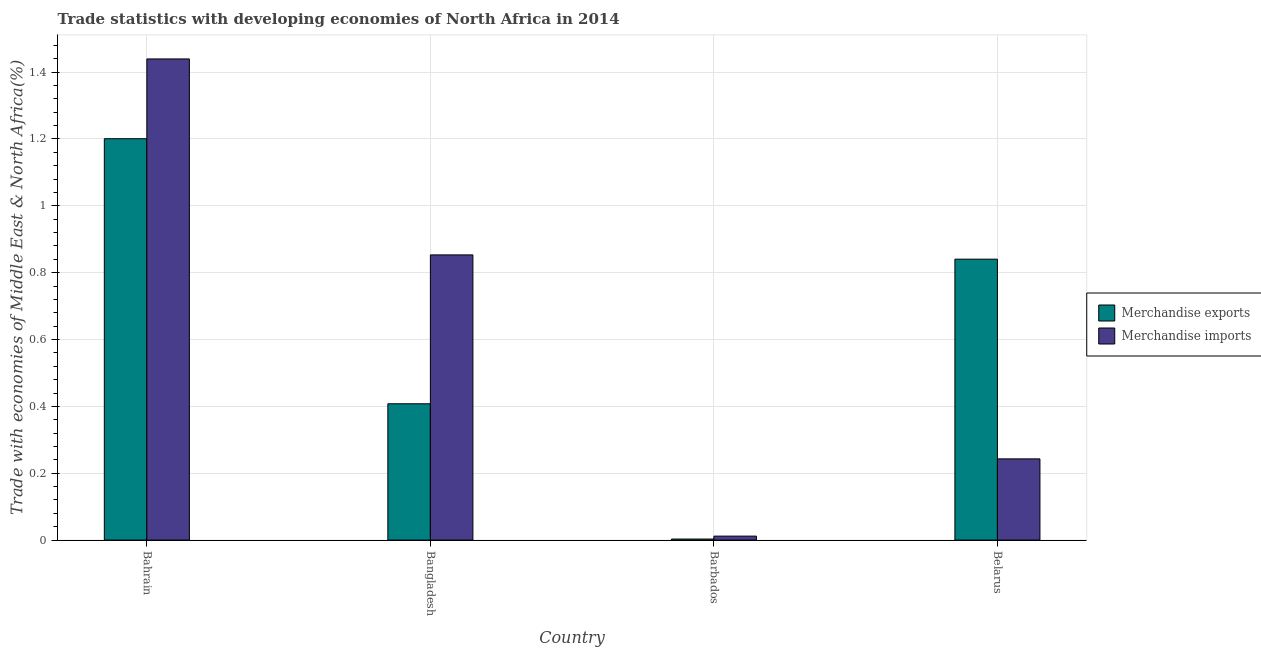Are the number of bars on each tick of the X-axis equal?
Your answer should be compact. Yes. How many bars are there on the 3rd tick from the left?
Ensure brevity in your answer.  2. How many bars are there on the 1st tick from the right?
Provide a short and direct response. 2. What is the label of the 2nd group of bars from the left?
Your answer should be compact. Bangladesh. In how many cases, is the number of bars for a given country not equal to the number of legend labels?
Keep it short and to the point. 0. What is the merchandise imports in Belarus?
Keep it short and to the point. 0.24. Across all countries, what is the maximum merchandise imports?
Your response must be concise. 1.44. Across all countries, what is the minimum merchandise imports?
Offer a terse response. 0.01. In which country was the merchandise exports maximum?
Keep it short and to the point. Bahrain. In which country was the merchandise exports minimum?
Provide a succinct answer. Barbados. What is the total merchandise imports in the graph?
Your answer should be very brief. 2.55. What is the difference between the merchandise exports in Bangladesh and that in Barbados?
Offer a very short reply. 0.4. What is the difference between the merchandise imports in Belarus and the merchandise exports in Barbados?
Your response must be concise. 0.24. What is the average merchandise imports per country?
Keep it short and to the point. 0.64. What is the difference between the merchandise exports and merchandise imports in Bangladesh?
Your answer should be compact. -0.45. In how many countries, is the merchandise imports greater than 0.6000000000000001 %?
Your answer should be very brief. 2. What is the ratio of the merchandise imports in Bangladesh to that in Belarus?
Make the answer very short. 3.51. Is the merchandise exports in Bahrain less than that in Barbados?
Your answer should be compact. No. What is the difference between the highest and the second highest merchandise exports?
Provide a succinct answer. 0.36. What is the difference between the highest and the lowest merchandise imports?
Your response must be concise. 1.43. What does the 2nd bar from the right in Barbados represents?
Your answer should be very brief. Merchandise exports. Does the graph contain grids?
Give a very brief answer. Yes. What is the title of the graph?
Your answer should be compact. Trade statistics with developing economies of North Africa in 2014. What is the label or title of the Y-axis?
Offer a very short reply. Trade with economies of Middle East & North Africa(%). What is the Trade with economies of Middle East & North Africa(%) in Merchandise exports in Bahrain?
Provide a succinct answer. 1.2. What is the Trade with economies of Middle East & North Africa(%) in Merchandise imports in Bahrain?
Offer a very short reply. 1.44. What is the Trade with economies of Middle East & North Africa(%) of Merchandise exports in Bangladesh?
Keep it short and to the point. 0.41. What is the Trade with economies of Middle East & North Africa(%) of Merchandise imports in Bangladesh?
Offer a very short reply. 0.85. What is the Trade with economies of Middle East & North Africa(%) in Merchandise exports in Barbados?
Give a very brief answer. 0. What is the Trade with economies of Middle East & North Africa(%) of Merchandise imports in Barbados?
Your answer should be very brief. 0.01. What is the Trade with economies of Middle East & North Africa(%) of Merchandise exports in Belarus?
Offer a terse response. 0.84. What is the Trade with economies of Middle East & North Africa(%) in Merchandise imports in Belarus?
Your response must be concise. 0.24. Across all countries, what is the maximum Trade with economies of Middle East & North Africa(%) in Merchandise exports?
Your response must be concise. 1.2. Across all countries, what is the maximum Trade with economies of Middle East & North Africa(%) in Merchandise imports?
Make the answer very short. 1.44. Across all countries, what is the minimum Trade with economies of Middle East & North Africa(%) in Merchandise exports?
Make the answer very short. 0. Across all countries, what is the minimum Trade with economies of Middle East & North Africa(%) of Merchandise imports?
Your answer should be compact. 0.01. What is the total Trade with economies of Middle East & North Africa(%) of Merchandise exports in the graph?
Offer a terse response. 2.45. What is the total Trade with economies of Middle East & North Africa(%) in Merchandise imports in the graph?
Ensure brevity in your answer.  2.55. What is the difference between the Trade with economies of Middle East & North Africa(%) of Merchandise exports in Bahrain and that in Bangladesh?
Your answer should be very brief. 0.79. What is the difference between the Trade with economies of Middle East & North Africa(%) in Merchandise imports in Bahrain and that in Bangladesh?
Offer a terse response. 0.59. What is the difference between the Trade with economies of Middle East & North Africa(%) of Merchandise exports in Bahrain and that in Barbados?
Make the answer very short. 1.2. What is the difference between the Trade with economies of Middle East & North Africa(%) in Merchandise imports in Bahrain and that in Barbados?
Offer a very short reply. 1.43. What is the difference between the Trade with economies of Middle East & North Africa(%) of Merchandise exports in Bahrain and that in Belarus?
Provide a succinct answer. 0.36. What is the difference between the Trade with economies of Middle East & North Africa(%) in Merchandise imports in Bahrain and that in Belarus?
Provide a short and direct response. 1.2. What is the difference between the Trade with economies of Middle East & North Africa(%) of Merchandise exports in Bangladesh and that in Barbados?
Your response must be concise. 0.4. What is the difference between the Trade with economies of Middle East & North Africa(%) in Merchandise imports in Bangladesh and that in Barbados?
Ensure brevity in your answer.  0.84. What is the difference between the Trade with economies of Middle East & North Africa(%) of Merchandise exports in Bangladesh and that in Belarus?
Offer a terse response. -0.43. What is the difference between the Trade with economies of Middle East & North Africa(%) in Merchandise imports in Bangladesh and that in Belarus?
Keep it short and to the point. 0.61. What is the difference between the Trade with economies of Middle East & North Africa(%) of Merchandise exports in Barbados and that in Belarus?
Provide a succinct answer. -0.84. What is the difference between the Trade with economies of Middle East & North Africa(%) of Merchandise imports in Barbados and that in Belarus?
Ensure brevity in your answer.  -0.23. What is the difference between the Trade with economies of Middle East & North Africa(%) of Merchandise exports in Bahrain and the Trade with economies of Middle East & North Africa(%) of Merchandise imports in Bangladesh?
Keep it short and to the point. 0.35. What is the difference between the Trade with economies of Middle East & North Africa(%) of Merchandise exports in Bahrain and the Trade with economies of Middle East & North Africa(%) of Merchandise imports in Barbados?
Offer a terse response. 1.19. What is the difference between the Trade with economies of Middle East & North Africa(%) in Merchandise exports in Bahrain and the Trade with economies of Middle East & North Africa(%) in Merchandise imports in Belarus?
Provide a succinct answer. 0.96. What is the difference between the Trade with economies of Middle East & North Africa(%) in Merchandise exports in Bangladesh and the Trade with economies of Middle East & North Africa(%) in Merchandise imports in Barbados?
Ensure brevity in your answer.  0.4. What is the difference between the Trade with economies of Middle East & North Africa(%) in Merchandise exports in Bangladesh and the Trade with economies of Middle East & North Africa(%) in Merchandise imports in Belarus?
Your response must be concise. 0.16. What is the difference between the Trade with economies of Middle East & North Africa(%) in Merchandise exports in Barbados and the Trade with economies of Middle East & North Africa(%) in Merchandise imports in Belarus?
Provide a succinct answer. -0.24. What is the average Trade with economies of Middle East & North Africa(%) of Merchandise exports per country?
Ensure brevity in your answer.  0.61. What is the average Trade with economies of Middle East & North Africa(%) in Merchandise imports per country?
Offer a terse response. 0.64. What is the difference between the Trade with economies of Middle East & North Africa(%) of Merchandise exports and Trade with economies of Middle East & North Africa(%) of Merchandise imports in Bahrain?
Your answer should be compact. -0.24. What is the difference between the Trade with economies of Middle East & North Africa(%) of Merchandise exports and Trade with economies of Middle East & North Africa(%) of Merchandise imports in Bangladesh?
Provide a succinct answer. -0.45. What is the difference between the Trade with economies of Middle East & North Africa(%) of Merchandise exports and Trade with economies of Middle East & North Africa(%) of Merchandise imports in Barbados?
Ensure brevity in your answer.  -0.01. What is the difference between the Trade with economies of Middle East & North Africa(%) of Merchandise exports and Trade with economies of Middle East & North Africa(%) of Merchandise imports in Belarus?
Your answer should be compact. 0.6. What is the ratio of the Trade with economies of Middle East & North Africa(%) of Merchandise exports in Bahrain to that in Bangladesh?
Provide a short and direct response. 2.94. What is the ratio of the Trade with economies of Middle East & North Africa(%) in Merchandise imports in Bahrain to that in Bangladesh?
Provide a succinct answer. 1.69. What is the ratio of the Trade with economies of Middle East & North Africa(%) of Merchandise exports in Bahrain to that in Barbados?
Ensure brevity in your answer.  382.31. What is the ratio of the Trade with economies of Middle East & North Africa(%) of Merchandise imports in Bahrain to that in Barbados?
Give a very brief answer. 120.99. What is the ratio of the Trade with economies of Middle East & North Africa(%) in Merchandise exports in Bahrain to that in Belarus?
Give a very brief answer. 1.43. What is the ratio of the Trade with economies of Middle East & North Africa(%) of Merchandise imports in Bahrain to that in Belarus?
Provide a short and direct response. 5.92. What is the ratio of the Trade with economies of Middle East & North Africa(%) of Merchandise exports in Bangladesh to that in Barbados?
Provide a short and direct response. 129.84. What is the ratio of the Trade with economies of Middle East & North Africa(%) in Merchandise imports in Bangladesh to that in Barbados?
Make the answer very short. 71.71. What is the ratio of the Trade with economies of Middle East & North Africa(%) of Merchandise exports in Bangladesh to that in Belarus?
Your answer should be compact. 0.49. What is the ratio of the Trade with economies of Middle East & North Africa(%) in Merchandise imports in Bangladesh to that in Belarus?
Give a very brief answer. 3.51. What is the ratio of the Trade with economies of Middle East & North Africa(%) of Merchandise exports in Barbados to that in Belarus?
Your answer should be very brief. 0. What is the ratio of the Trade with economies of Middle East & North Africa(%) of Merchandise imports in Barbados to that in Belarus?
Your answer should be compact. 0.05. What is the difference between the highest and the second highest Trade with economies of Middle East & North Africa(%) in Merchandise exports?
Provide a short and direct response. 0.36. What is the difference between the highest and the second highest Trade with economies of Middle East & North Africa(%) in Merchandise imports?
Provide a succinct answer. 0.59. What is the difference between the highest and the lowest Trade with economies of Middle East & North Africa(%) in Merchandise exports?
Your answer should be compact. 1.2. What is the difference between the highest and the lowest Trade with economies of Middle East & North Africa(%) in Merchandise imports?
Your answer should be very brief. 1.43. 